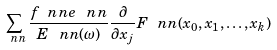Convert formula to latex. <formula><loc_0><loc_0><loc_500><loc_500>\sum _ { \ n n } \frac { f _ { \ } n n e _ { \ } n n } { E _ { \ } n n ( \omega ) } \frac { \partial } { \partial x _ { j } } F _ { \ } n n ( x _ { 0 } , x _ { 1 } , \dots , x _ { k } )</formula> 